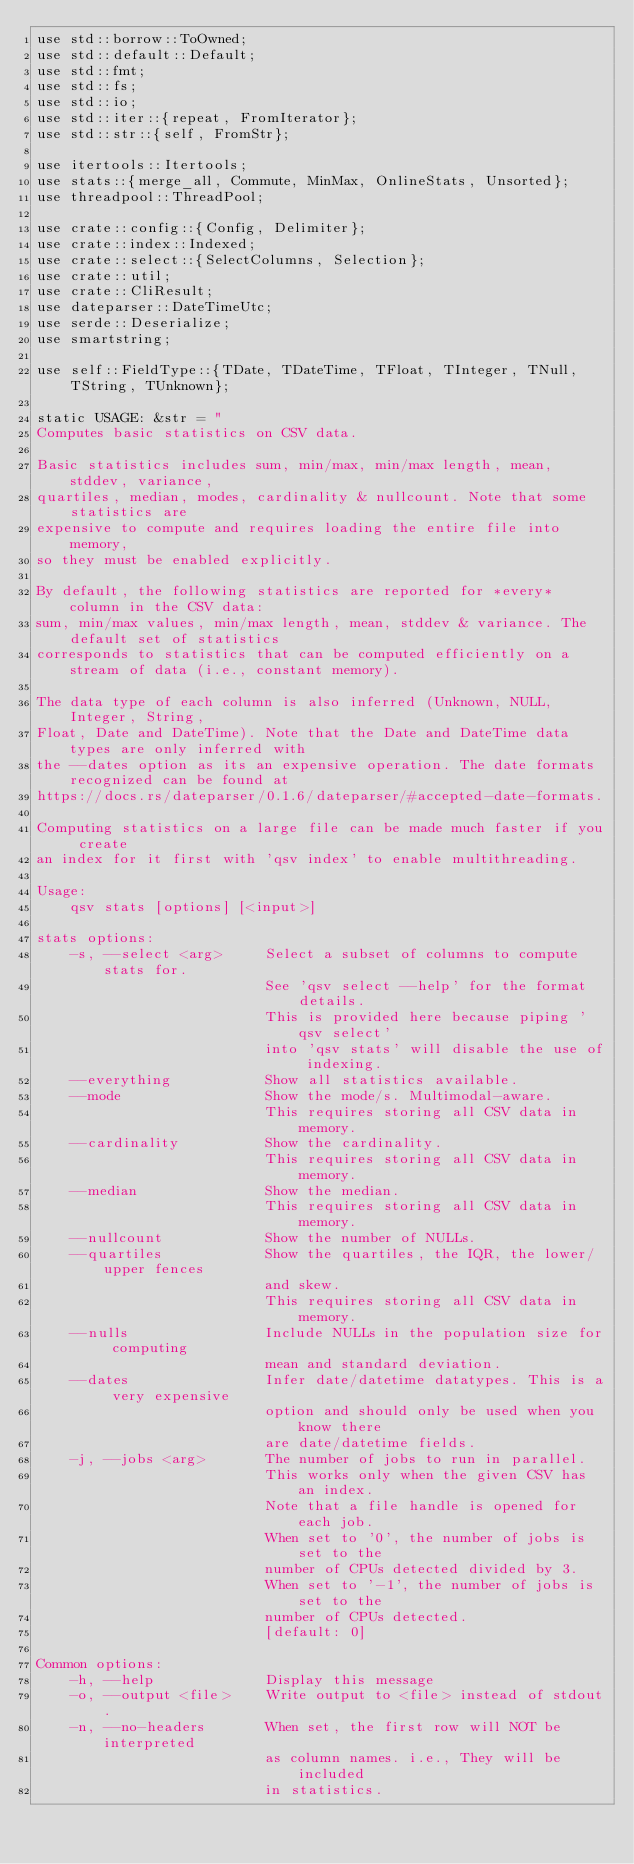Convert code to text. <code><loc_0><loc_0><loc_500><loc_500><_Rust_>use std::borrow::ToOwned;
use std::default::Default;
use std::fmt;
use std::fs;
use std::io;
use std::iter::{repeat, FromIterator};
use std::str::{self, FromStr};

use itertools::Itertools;
use stats::{merge_all, Commute, MinMax, OnlineStats, Unsorted};
use threadpool::ThreadPool;

use crate::config::{Config, Delimiter};
use crate::index::Indexed;
use crate::select::{SelectColumns, Selection};
use crate::util;
use crate::CliResult;
use dateparser::DateTimeUtc;
use serde::Deserialize;
use smartstring;

use self::FieldType::{TDate, TDateTime, TFloat, TInteger, TNull, TString, TUnknown};

static USAGE: &str = "
Computes basic statistics on CSV data.

Basic statistics includes sum, min/max, min/max length, mean, stddev, variance,
quartiles, median, modes, cardinality & nullcount. Note that some statistics are
expensive to compute and requires loading the entire file into memory,
so they must be enabled explicitly. 

By default, the following statistics are reported for *every* column in the CSV data:
sum, min/max values, min/max length, mean, stddev & variance. The default set of statistics 
corresponds to statistics that can be computed efficiently on a stream of data (i.e., constant memory).

The data type of each column is also inferred (Unknown, NULL, Integer, String,
Float, Date and DateTime). Note that the Date and DateTime data types are only inferred with
the --dates option as its an expensive operation. The date formats recognized can be found at
https://docs.rs/dateparser/0.1.6/dateparser/#accepted-date-formats.

Computing statistics on a large file can be made much faster if you create
an index for it first with 'qsv index' to enable multithreading.

Usage:
    qsv stats [options] [<input>]

stats options:
    -s, --select <arg>     Select a subset of columns to compute stats for.
                           See 'qsv select --help' for the format details.
                           This is provided here because piping 'qsv select'
                           into 'qsv stats' will disable the use of indexing.
    --everything           Show all statistics available.
    --mode                 Show the mode/s. Multimodal-aware.
                           This requires storing all CSV data in memory.
    --cardinality          Show the cardinality.
                           This requires storing all CSV data in memory.
    --median               Show the median.
                           This requires storing all CSV data in memory.
    --nullcount            Show the number of NULLs.
    --quartiles            Show the quartiles, the IQR, the lower/upper fences
                           and skew.
                           This requires storing all CSV data in memory.
    --nulls                Include NULLs in the population size for computing
                           mean and standard deviation.
    --dates                Infer date/datetime datatypes. This is a very expensive
                           option and should only be used when you know there
                           are date/datetime fields.
    -j, --jobs <arg>       The number of jobs to run in parallel.
                           This works only when the given CSV has an index.
                           Note that a file handle is opened for each job.
                           When set to '0', the number of jobs is set to the
                           number of CPUs detected divided by 3.
                           When set to '-1', the number of jobs is set to the
                           number of CPUs detected.
                           [default: 0]

Common options:
    -h, --help             Display this message
    -o, --output <file>    Write output to <file> instead of stdout.
    -n, --no-headers       When set, the first row will NOT be interpreted
                           as column names. i.e., They will be included
                           in statistics.</code> 